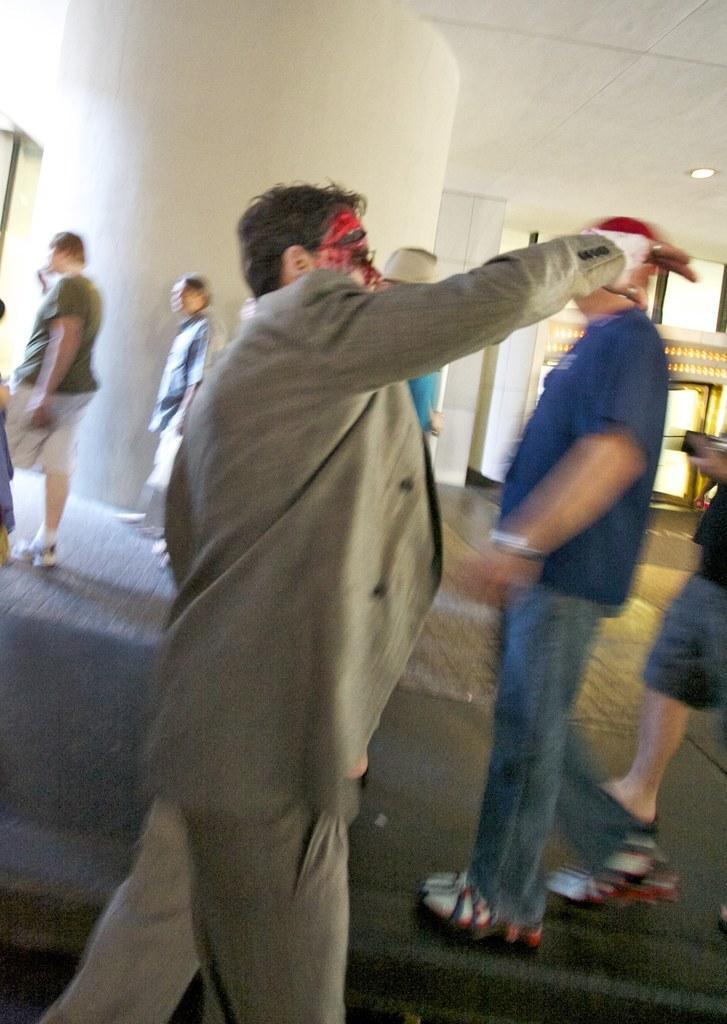Can you describe this image briefly? In this picture there is a man who is wearing spectacle suit and trouser. On the right there is a woman who is wearing black dress. She is standing near to the man who is wearing blue shirt, jeans, watch and shoe. On the left two person standing near to the pillar. Here we can see lights. 